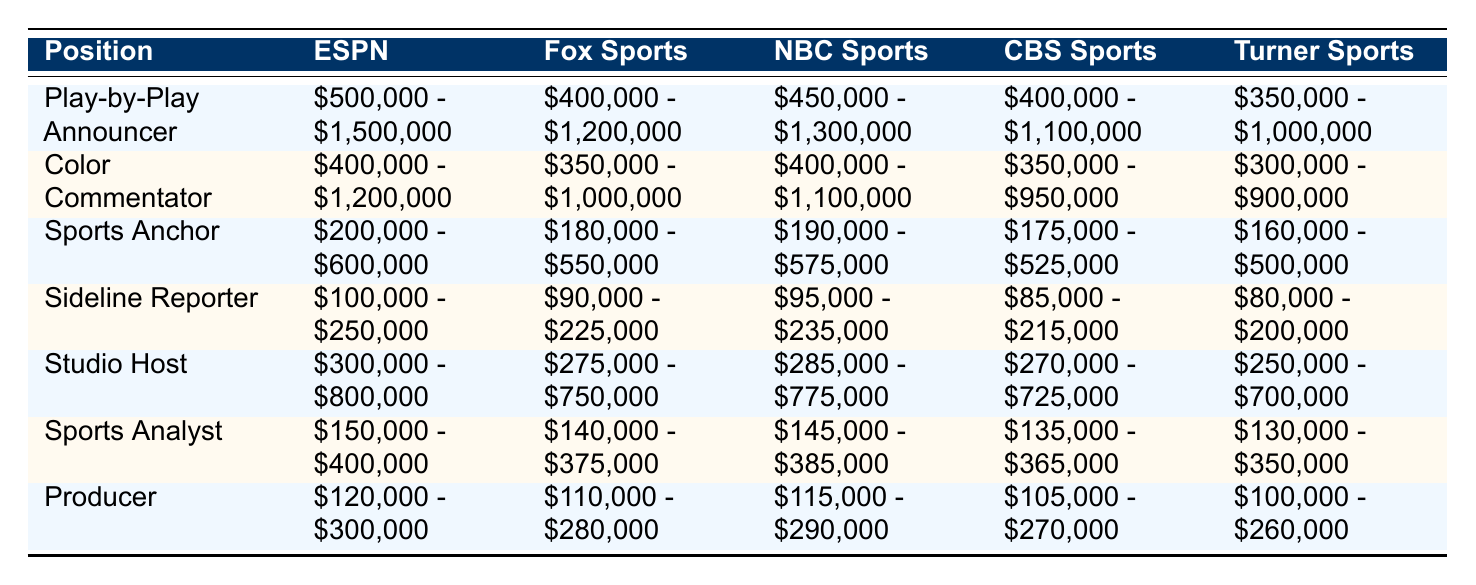What is the salary range for a Play-by-Play Announcer at ESPN? The table shows that the salary range for a Play-by-Play Announcer at ESPN is between $500,000 and $1,500,000.
Answer: $500,000 - $1,500,000 Which network offers the lowest salary range for a Sideline Reporter? By examining the Sideline Reporter row, the lowest salary range is found at Turner Sports, which offers $80,000 to $200,000.
Answer: Turner Sports What is the average maximum salary for Sports Anchors across all networks? The maximum salaries for Sports Anchors are: ESPN $600,000, Fox Sports $550,000, NBC Sports $575,000, CBS Sports $525,000, and Turner Sports $500,000. The sum is $600,000 + $550,000 + $575,000 + $525,000 + $500,000 = $2,750,000. Dividing by 5 gives an average of $2,750,000 / 5 = $550,000.
Answer: $550,000 Is the salary range for a Color Commentator at NBC Sports higher than that at CBS Sports? The salary range for a Color Commentator at NBC Sports is $400,000 - $1,100,000, while CBS Sports offers $350,000 - $950,000. Since both ranges are compared here, NBC Sports has a higher lower bound as well as a higher upper bound. Therefore, the statement is true.
Answer: Yes What is the difference between the highest and lowest salary ranges for Producers across all networks? The highest salary range for a Producer is at ESPN: $120,000 - $300,000. The lowest is at Turner Sports: $100,000 - $260,000. The difference in the upper limits is $300,000 - $260,000 = $40,000. The difference in the lower limits is $120,000 - $100,000 = $20,000. Therefore, the overall difference is maximum of the two, which is $40,000.
Answer: $40,000 Which position at CBS Sports has the highest maximum salary? Looking at the maximum salaries for each position at CBS Sports: Play-by-Play Announcer $1,100,000, Color Commentator $950,000, Sports Anchor $525,000, Sideline Reporter $215,000, Studio Host $725,000, Sports Analyst $365,000, and Producer $270,000. The highest is for the Play-by-Play Announcer.
Answer: Play-by-Play Announcer How does the average minimum salary for Studio Hosts compare to that for Sports Analysts? The minimum salaries for Studio Hosts across networks are: ESPN $300,000, Fox Sports $275,000, NBC Sports $285,000, CBS Sports $270,000, Turner Sports $250,000. Summing these gives $1,380,000, so the average is $1,380,000 / 5 = $276,000. For Sports Analysts, the minimums are: ESPN $150,000, Fox Sports $140,000, NBC Sports $145,000, CBS Sports $135,000, Turner Sports $130,000, which gives $700,000; average = $700,000 / 5 = $140,000. Finally, $276,000 is greater than $140,000, so the Studio Host's average is higher.
Answer: Studio Hosts are higher 